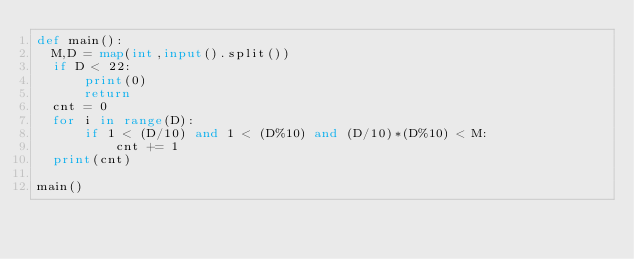<code> <loc_0><loc_0><loc_500><loc_500><_Python_>def main():
  M,D = map(int,input().split())
  if D < 22:
      print(0)
      return
  cnt = 0
  for i in range(D):
      if 1 < (D/10) and 1 < (D%10) and (D/10)*(D%10) < M:
          cnt += 1
  print(cnt)
  
main()</code> 